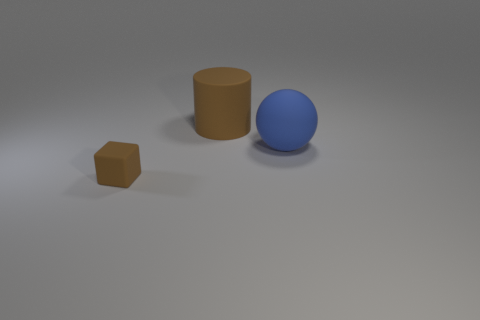Subtract all cubes. How many objects are left? 2 Subtract 1 spheres. How many spheres are left? 0 Add 1 small objects. How many small objects exist? 2 Add 2 brown blocks. How many objects exist? 5 Subtract 0 gray balls. How many objects are left? 3 Subtract all red blocks. Subtract all cyan cylinders. How many blocks are left? 1 Subtract all large blue spheres. Subtract all big brown cylinders. How many objects are left? 1 Add 2 large rubber cylinders. How many large rubber cylinders are left? 3 